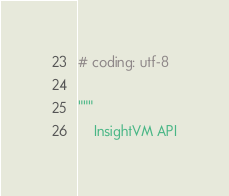<code> <loc_0><loc_0><loc_500><loc_500><_Python_># coding: utf-8

"""
    InsightVM API
</code> 